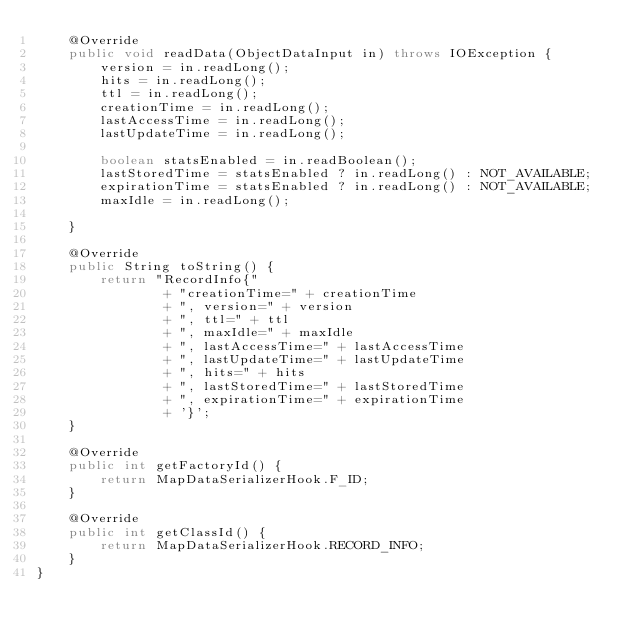<code> <loc_0><loc_0><loc_500><loc_500><_Java_>    @Override
    public void readData(ObjectDataInput in) throws IOException {
        version = in.readLong();
        hits = in.readLong();
        ttl = in.readLong();
        creationTime = in.readLong();
        lastAccessTime = in.readLong();
        lastUpdateTime = in.readLong();

        boolean statsEnabled = in.readBoolean();
        lastStoredTime = statsEnabled ? in.readLong() : NOT_AVAILABLE;
        expirationTime = statsEnabled ? in.readLong() : NOT_AVAILABLE;
        maxIdle = in.readLong();

    }

    @Override
    public String toString() {
        return "RecordInfo{"
                + "creationTime=" + creationTime
                + ", version=" + version
                + ", ttl=" + ttl
                + ", maxIdle=" + maxIdle
                + ", lastAccessTime=" + lastAccessTime
                + ", lastUpdateTime=" + lastUpdateTime
                + ", hits=" + hits
                + ", lastStoredTime=" + lastStoredTime
                + ", expirationTime=" + expirationTime
                + '}';
    }

    @Override
    public int getFactoryId() {
        return MapDataSerializerHook.F_ID;
    }

    @Override
    public int getClassId() {
        return MapDataSerializerHook.RECORD_INFO;
    }
}
</code> 